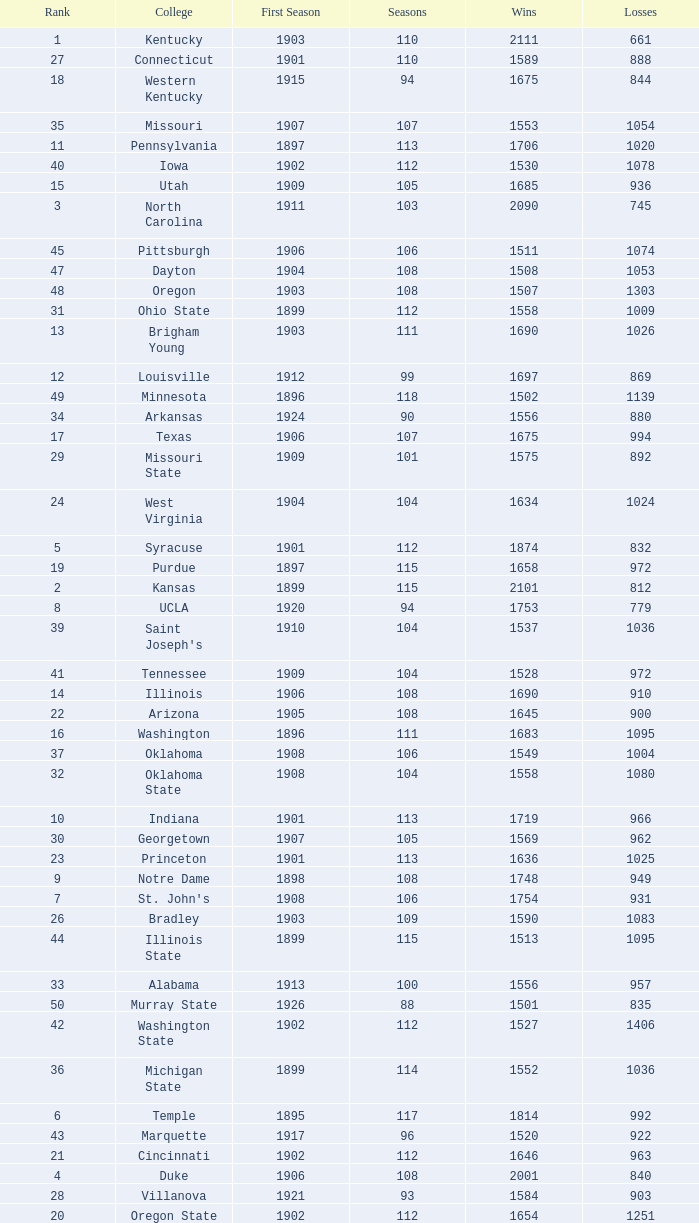Can you give me this table as a dict? {'header': ['Rank', 'College', 'First Season', 'Seasons', 'Wins', 'Losses'], 'rows': [['1', 'Kentucky', '1903', '110', '2111', '661'], ['27', 'Connecticut', '1901', '110', '1589', '888'], ['18', 'Western Kentucky', '1915', '94', '1675', '844'], ['35', 'Missouri', '1907', '107', '1553', '1054'], ['11', 'Pennsylvania', '1897', '113', '1706', '1020'], ['40', 'Iowa', '1902', '112', '1530', '1078'], ['15', 'Utah', '1909', '105', '1685', '936'], ['3', 'North Carolina', '1911', '103', '2090', '745'], ['45', 'Pittsburgh', '1906', '106', '1511', '1074'], ['47', 'Dayton', '1904', '108', '1508', '1053'], ['48', 'Oregon', '1903', '108', '1507', '1303'], ['31', 'Ohio State', '1899', '112', '1558', '1009'], ['13', 'Brigham Young', '1903', '111', '1690', '1026'], ['12', 'Louisville', '1912', '99', '1697', '869'], ['49', 'Minnesota', '1896', '118', '1502', '1139'], ['34', 'Arkansas', '1924', '90', '1556', '880'], ['17', 'Texas', '1906', '107', '1675', '994'], ['29', 'Missouri State', '1909', '101', '1575', '892'], ['24', 'West Virginia', '1904', '104', '1634', '1024'], ['5', 'Syracuse', '1901', '112', '1874', '832'], ['19', 'Purdue', '1897', '115', '1658', '972'], ['2', 'Kansas', '1899', '115', '2101', '812'], ['8', 'UCLA', '1920', '94', '1753', '779'], ['39', "Saint Joseph's", '1910', '104', '1537', '1036'], ['41', 'Tennessee', '1909', '104', '1528', '972'], ['14', 'Illinois', '1906', '108', '1690', '910'], ['22', 'Arizona', '1905', '108', '1645', '900'], ['16', 'Washington', '1896', '111', '1683', '1095'], ['37', 'Oklahoma', '1908', '106', '1549', '1004'], ['32', 'Oklahoma State', '1908', '104', '1558', '1080'], ['10', 'Indiana', '1901', '113', '1719', '966'], ['30', 'Georgetown', '1907', '105', '1569', '962'], ['23', 'Princeton', '1901', '113', '1636', '1025'], ['9', 'Notre Dame', '1898', '108', '1748', '949'], ['7', "St. John's", '1908', '106', '1754', '931'], ['26', 'Bradley', '1903', '109', '1590', '1083'], ['44', 'Illinois State', '1899', '115', '1513', '1095'], ['33', 'Alabama', '1913', '100', '1556', '957'], ['50', 'Murray State', '1926', '88', '1501', '835'], ['42', 'Washington State', '1902', '112', '1527', '1406'], ['36', 'Michigan State', '1899', '114', '1552', '1036'], ['6', 'Temple', '1895', '117', '1814', '992'], ['43', 'Marquette', '1917', '96', '1520', '922'], ['21', 'Cincinnati', '1902', '112', '1646', '963'], ['4', 'Duke', '1906', '108', '2001', '840'], ['28', 'Villanova', '1921', '93', '1584', '903'], ['20', 'Oregon State', '1902', '112', '1654', '1251'], ['25', 'North Carolina State', '1913', '101', '1617', '980'], ['38', 'Kansas State', '1903', '109', '1537', '1075'], ['46', 'Vanderbilt', '1901', '111', '1511', '1063']]} How many wins were there for Washington State College with losses greater than 980 and a first season before 1906 and rank greater than 42? 0.0. 